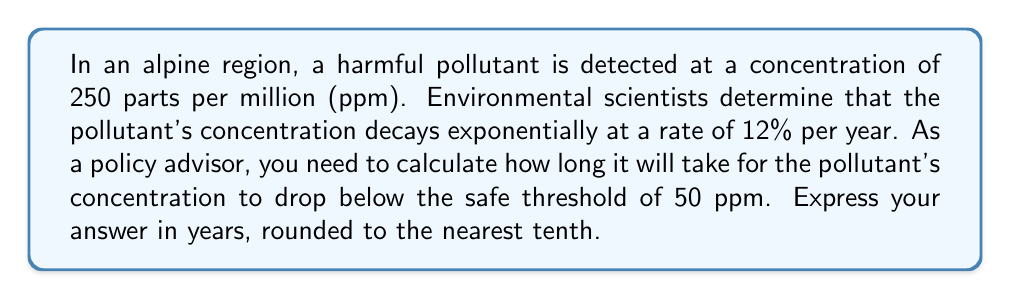Give your solution to this math problem. Let's approach this step-by-step using an exponential decay function:

1) The general form of exponential decay is:
   $$ A(t) = A_0 \cdot (1-r)^t $$
   where $A(t)$ is the amount at time $t$, $A_0$ is the initial amount, $r$ is the decay rate, and $t$ is time.

2) We have:
   $A_0 = 250$ ppm (initial concentration)
   $r = 0.12$ (12% decay rate)
   We need to find $t$ when $A(t) = 50$ ppm

3) Substituting into the equation:
   $$ 50 = 250 \cdot (1-0.12)^t $$

4) Simplify:
   $$ 50 = 250 \cdot (0.88)^t $$

5) Divide both sides by 250:
   $$ \frac{1}{5} = (0.88)^t $$

6) Take the natural log of both sides:
   $$ \ln(\frac{1}{5}) = \ln((0.88)^t) $$

7) Use the log property $\ln(a^b) = b\ln(a)$:
   $$ \ln(\frac{1}{5}) = t \cdot \ln(0.88) $$

8) Solve for $t$:
   $$ t = \frac{\ln(\frac{1}{5})}{\ln(0.88)} $$

9) Calculate:
   $$ t \approx 13.7509 $$

10) Round to the nearest tenth:
    $t \approx 13.8$ years
Answer: 13.8 years 